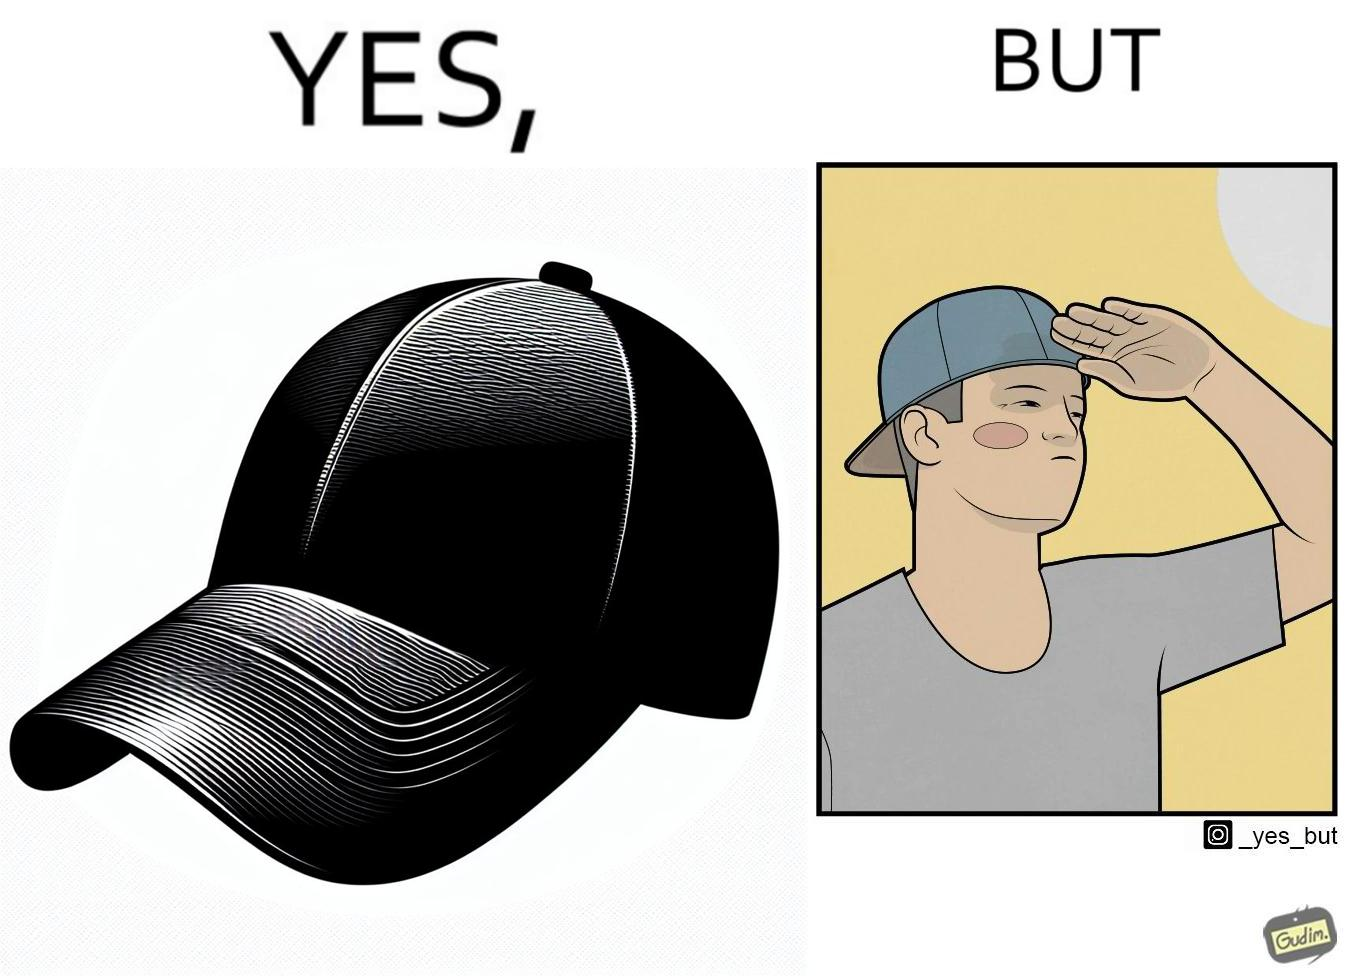What does this image depict? This image is funny because a cap is MEANT to protect one's eyes from the sun, but this person is more interested in using it to look stylish, even if it makes them uncomfortable. 